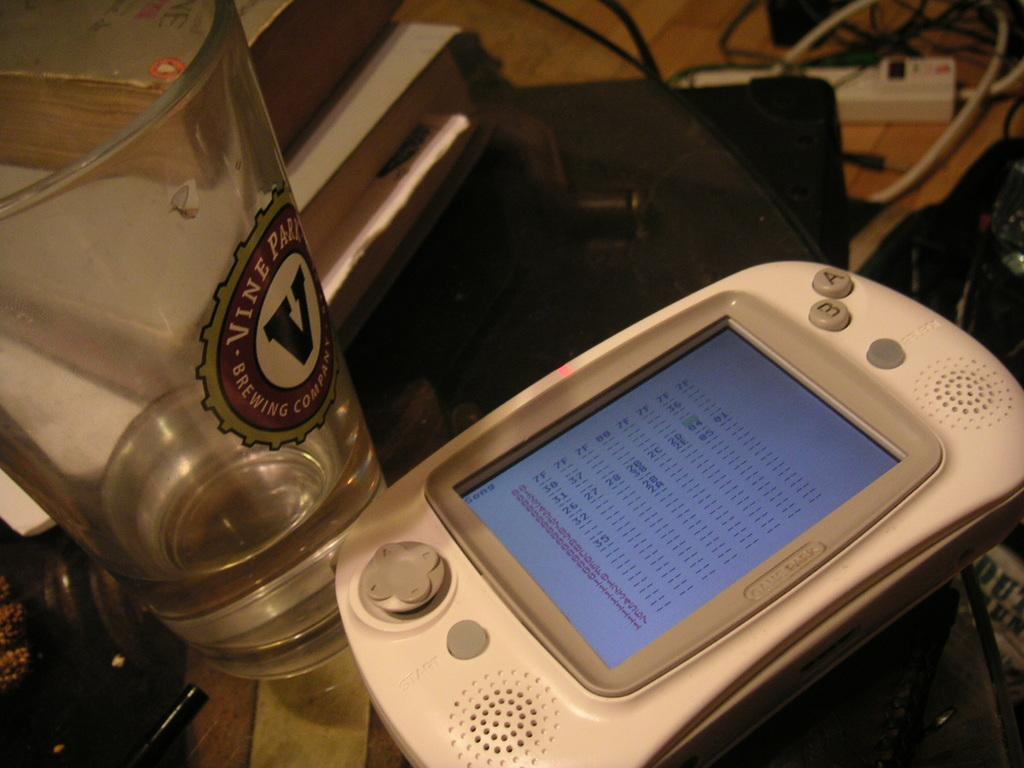<image>
Share a concise interpretation of the image provided. A handheld device on a table with a Vine Park Brewing Company glass. 